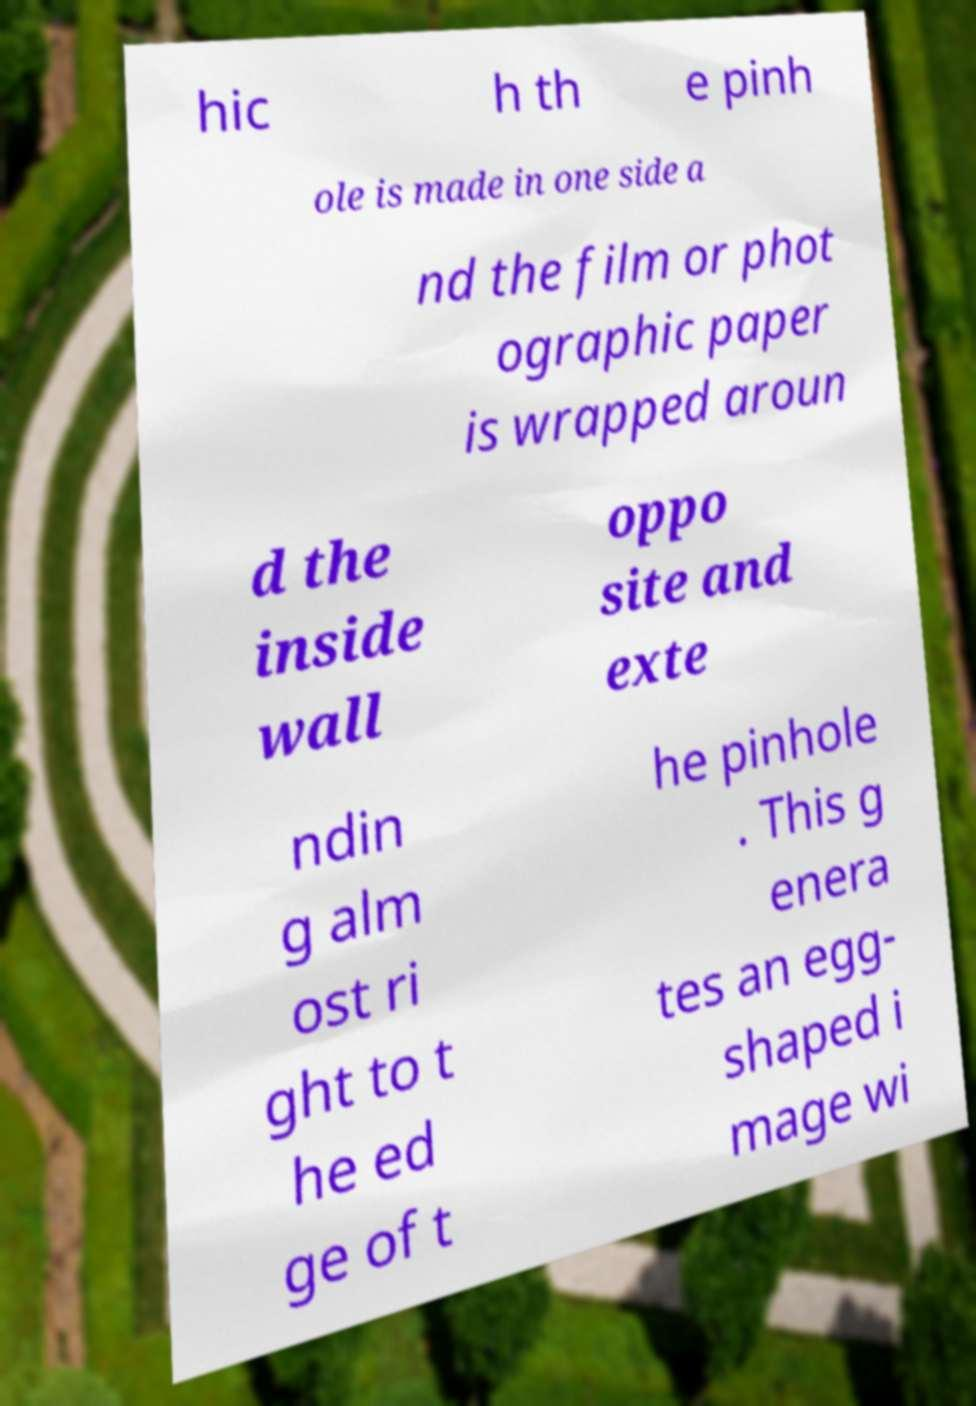I need the written content from this picture converted into text. Can you do that? hic h th e pinh ole is made in one side a nd the film or phot ographic paper is wrapped aroun d the inside wall oppo site and exte ndin g alm ost ri ght to t he ed ge of t he pinhole . This g enera tes an egg- shaped i mage wi 